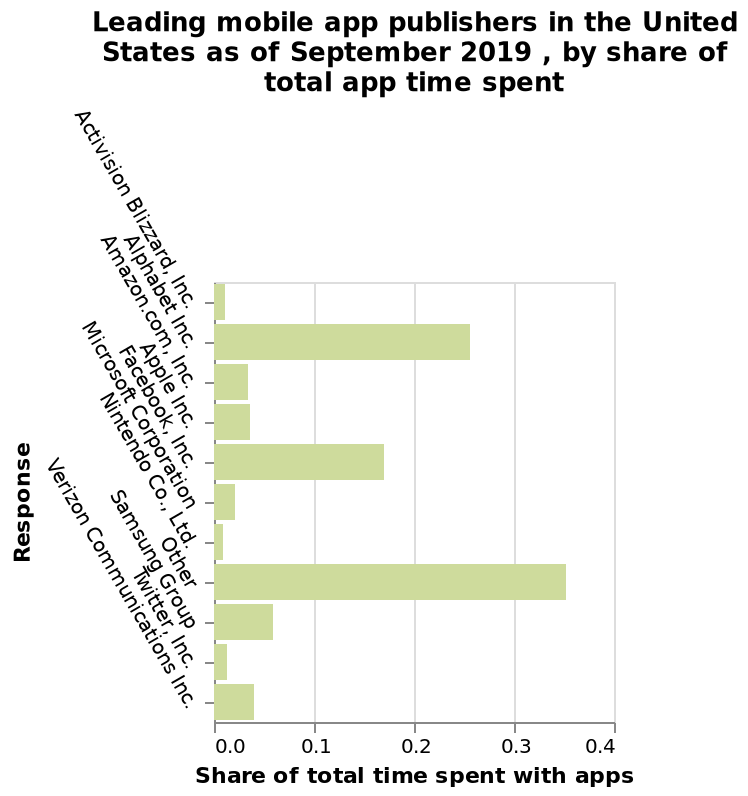<image>
please enumerates aspects of the construction of the chart Leading mobile app publishers in the United States as of September 2019 , by share of total app time spent is a bar chart. The y-axis plots Response while the x-axis shows Share of total time spent with apps. According to the September 2019 data, what does the bar chart depict? The bar chart depicts the leading mobile app publishers in the United States based on their share of total app time spent. 